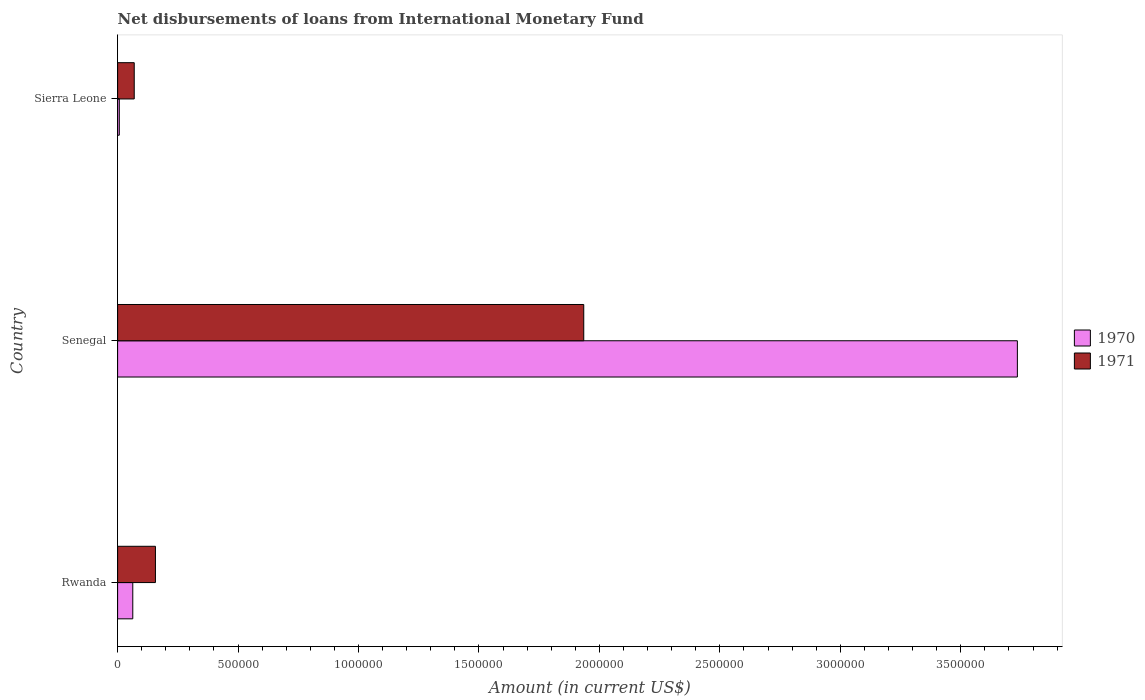How many groups of bars are there?
Your answer should be compact. 3. Are the number of bars per tick equal to the number of legend labels?
Provide a succinct answer. Yes. What is the label of the 3rd group of bars from the top?
Your response must be concise. Rwanda. In how many cases, is the number of bars for a given country not equal to the number of legend labels?
Make the answer very short. 0. What is the amount of loans disbursed in 1971 in Sierra Leone?
Provide a short and direct response. 6.90e+04. Across all countries, what is the maximum amount of loans disbursed in 1971?
Ensure brevity in your answer.  1.94e+06. Across all countries, what is the minimum amount of loans disbursed in 1970?
Your answer should be compact. 7000. In which country was the amount of loans disbursed in 1970 maximum?
Your response must be concise. Senegal. In which country was the amount of loans disbursed in 1970 minimum?
Offer a very short reply. Sierra Leone. What is the total amount of loans disbursed in 1970 in the graph?
Provide a succinct answer. 3.80e+06. What is the difference between the amount of loans disbursed in 1970 in Rwanda and that in Senegal?
Give a very brief answer. -3.67e+06. What is the difference between the amount of loans disbursed in 1970 in Rwanda and the amount of loans disbursed in 1971 in Senegal?
Make the answer very short. -1.87e+06. What is the average amount of loans disbursed in 1970 per country?
Make the answer very short. 1.27e+06. What is the difference between the amount of loans disbursed in 1971 and amount of loans disbursed in 1970 in Rwanda?
Offer a terse response. 9.40e+04. What is the ratio of the amount of loans disbursed in 1970 in Rwanda to that in Senegal?
Offer a terse response. 0.02. What is the difference between the highest and the second highest amount of loans disbursed in 1971?
Your answer should be compact. 1.78e+06. What is the difference between the highest and the lowest amount of loans disbursed in 1971?
Your answer should be compact. 1.87e+06. Is the sum of the amount of loans disbursed in 1970 in Senegal and Sierra Leone greater than the maximum amount of loans disbursed in 1971 across all countries?
Provide a short and direct response. Yes. Are all the bars in the graph horizontal?
Your response must be concise. Yes. How many countries are there in the graph?
Make the answer very short. 3. What is the difference between two consecutive major ticks on the X-axis?
Your answer should be compact. 5.00e+05. Are the values on the major ticks of X-axis written in scientific E-notation?
Give a very brief answer. No. Does the graph contain grids?
Your answer should be compact. No. Where does the legend appear in the graph?
Your answer should be compact. Center right. How are the legend labels stacked?
Your answer should be compact. Vertical. What is the title of the graph?
Your answer should be compact. Net disbursements of loans from International Monetary Fund. Does "1998" appear as one of the legend labels in the graph?
Provide a succinct answer. No. What is the label or title of the X-axis?
Provide a succinct answer. Amount (in current US$). What is the label or title of the Y-axis?
Provide a short and direct response. Country. What is the Amount (in current US$) of 1970 in Rwanda?
Your answer should be very brief. 6.30e+04. What is the Amount (in current US$) of 1971 in Rwanda?
Your response must be concise. 1.57e+05. What is the Amount (in current US$) in 1970 in Senegal?
Give a very brief answer. 3.74e+06. What is the Amount (in current US$) of 1971 in Senegal?
Your answer should be compact. 1.94e+06. What is the Amount (in current US$) in 1970 in Sierra Leone?
Provide a succinct answer. 7000. What is the Amount (in current US$) in 1971 in Sierra Leone?
Provide a short and direct response. 6.90e+04. Across all countries, what is the maximum Amount (in current US$) in 1970?
Make the answer very short. 3.74e+06. Across all countries, what is the maximum Amount (in current US$) of 1971?
Provide a succinct answer. 1.94e+06. Across all countries, what is the minimum Amount (in current US$) in 1970?
Provide a short and direct response. 7000. Across all countries, what is the minimum Amount (in current US$) of 1971?
Provide a succinct answer. 6.90e+04. What is the total Amount (in current US$) in 1970 in the graph?
Offer a terse response. 3.80e+06. What is the total Amount (in current US$) in 1971 in the graph?
Your answer should be very brief. 2.16e+06. What is the difference between the Amount (in current US$) of 1970 in Rwanda and that in Senegal?
Your answer should be very brief. -3.67e+06. What is the difference between the Amount (in current US$) in 1971 in Rwanda and that in Senegal?
Ensure brevity in your answer.  -1.78e+06. What is the difference between the Amount (in current US$) in 1970 in Rwanda and that in Sierra Leone?
Provide a short and direct response. 5.60e+04. What is the difference between the Amount (in current US$) of 1971 in Rwanda and that in Sierra Leone?
Provide a succinct answer. 8.80e+04. What is the difference between the Amount (in current US$) of 1970 in Senegal and that in Sierra Leone?
Provide a short and direct response. 3.73e+06. What is the difference between the Amount (in current US$) of 1971 in Senegal and that in Sierra Leone?
Offer a terse response. 1.87e+06. What is the difference between the Amount (in current US$) in 1970 in Rwanda and the Amount (in current US$) in 1971 in Senegal?
Ensure brevity in your answer.  -1.87e+06. What is the difference between the Amount (in current US$) in 1970 in Rwanda and the Amount (in current US$) in 1971 in Sierra Leone?
Offer a terse response. -6000. What is the difference between the Amount (in current US$) of 1970 in Senegal and the Amount (in current US$) of 1971 in Sierra Leone?
Provide a succinct answer. 3.67e+06. What is the average Amount (in current US$) in 1970 per country?
Offer a terse response. 1.27e+06. What is the average Amount (in current US$) in 1971 per country?
Your answer should be very brief. 7.20e+05. What is the difference between the Amount (in current US$) of 1970 and Amount (in current US$) of 1971 in Rwanda?
Your answer should be very brief. -9.40e+04. What is the difference between the Amount (in current US$) in 1970 and Amount (in current US$) in 1971 in Senegal?
Your answer should be very brief. 1.80e+06. What is the difference between the Amount (in current US$) of 1970 and Amount (in current US$) of 1971 in Sierra Leone?
Ensure brevity in your answer.  -6.20e+04. What is the ratio of the Amount (in current US$) in 1970 in Rwanda to that in Senegal?
Provide a short and direct response. 0.02. What is the ratio of the Amount (in current US$) in 1971 in Rwanda to that in Senegal?
Provide a succinct answer. 0.08. What is the ratio of the Amount (in current US$) in 1971 in Rwanda to that in Sierra Leone?
Your response must be concise. 2.28. What is the ratio of the Amount (in current US$) of 1970 in Senegal to that in Sierra Leone?
Offer a terse response. 533.57. What is the ratio of the Amount (in current US$) of 1971 in Senegal to that in Sierra Leone?
Make the answer very short. 28.04. What is the difference between the highest and the second highest Amount (in current US$) of 1970?
Ensure brevity in your answer.  3.67e+06. What is the difference between the highest and the second highest Amount (in current US$) of 1971?
Make the answer very short. 1.78e+06. What is the difference between the highest and the lowest Amount (in current US$) in 1970?
Keep it short and to the point. 3.73e+06. What is the difference between the highest and the lowest Amount (in current US$) of 1971?
Make the answer very short. 1.87e+06. 